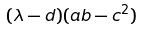Convert formula to latex. <formula><loc_0><loc_0><loc_500><loc_500>( \lambda - d ) ( a b - c ^ { 2 } )</formula> 